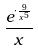Convert formula to latex. <formula><loc_0><loc_0><loc_500><loc_500>\frac { e ^ { \cdot \frac { 9 } { x ^ { 5 } } } } { x }</formula> 